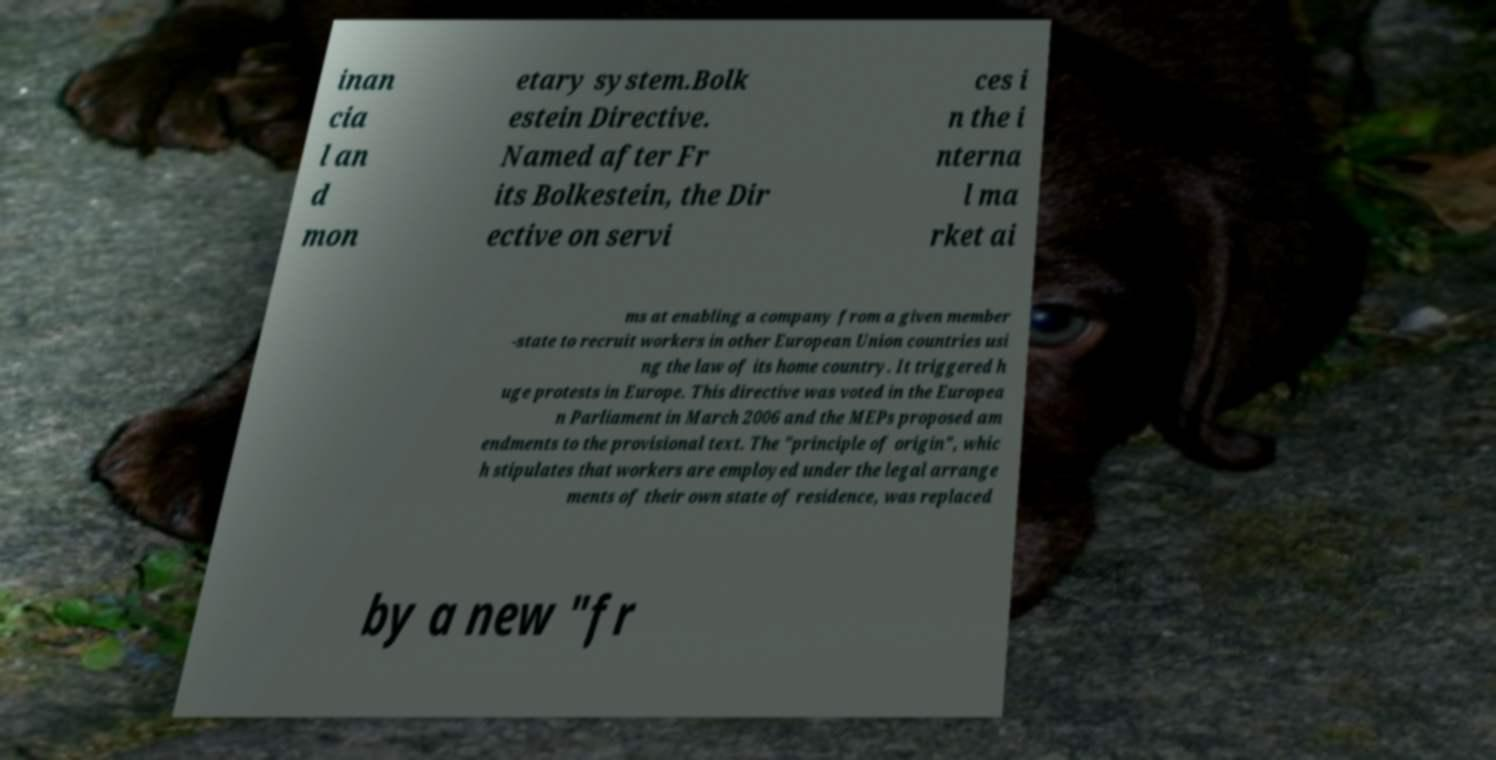I need the written content from this picture converted into text. Can you do that? inan cia l an d mon etary system.Bolk estein Directive. Named after Fr its Bolkestein, the Dir ective on servi ces i n the i nterna l ma rket ai ms at enabling a company from a given member -state to recruit workers in other European Union countries usi ng the law of its home country. It triggered h uge protests in Europe. This directive was voted in the Europea n Parliament in March 2006 and the MEPs proposed am endments to the provisional text. The "principle of origin", whic h stipulates that workers are employed under the legal arrange ments of their own state of residence, was replaced by a new "fr 